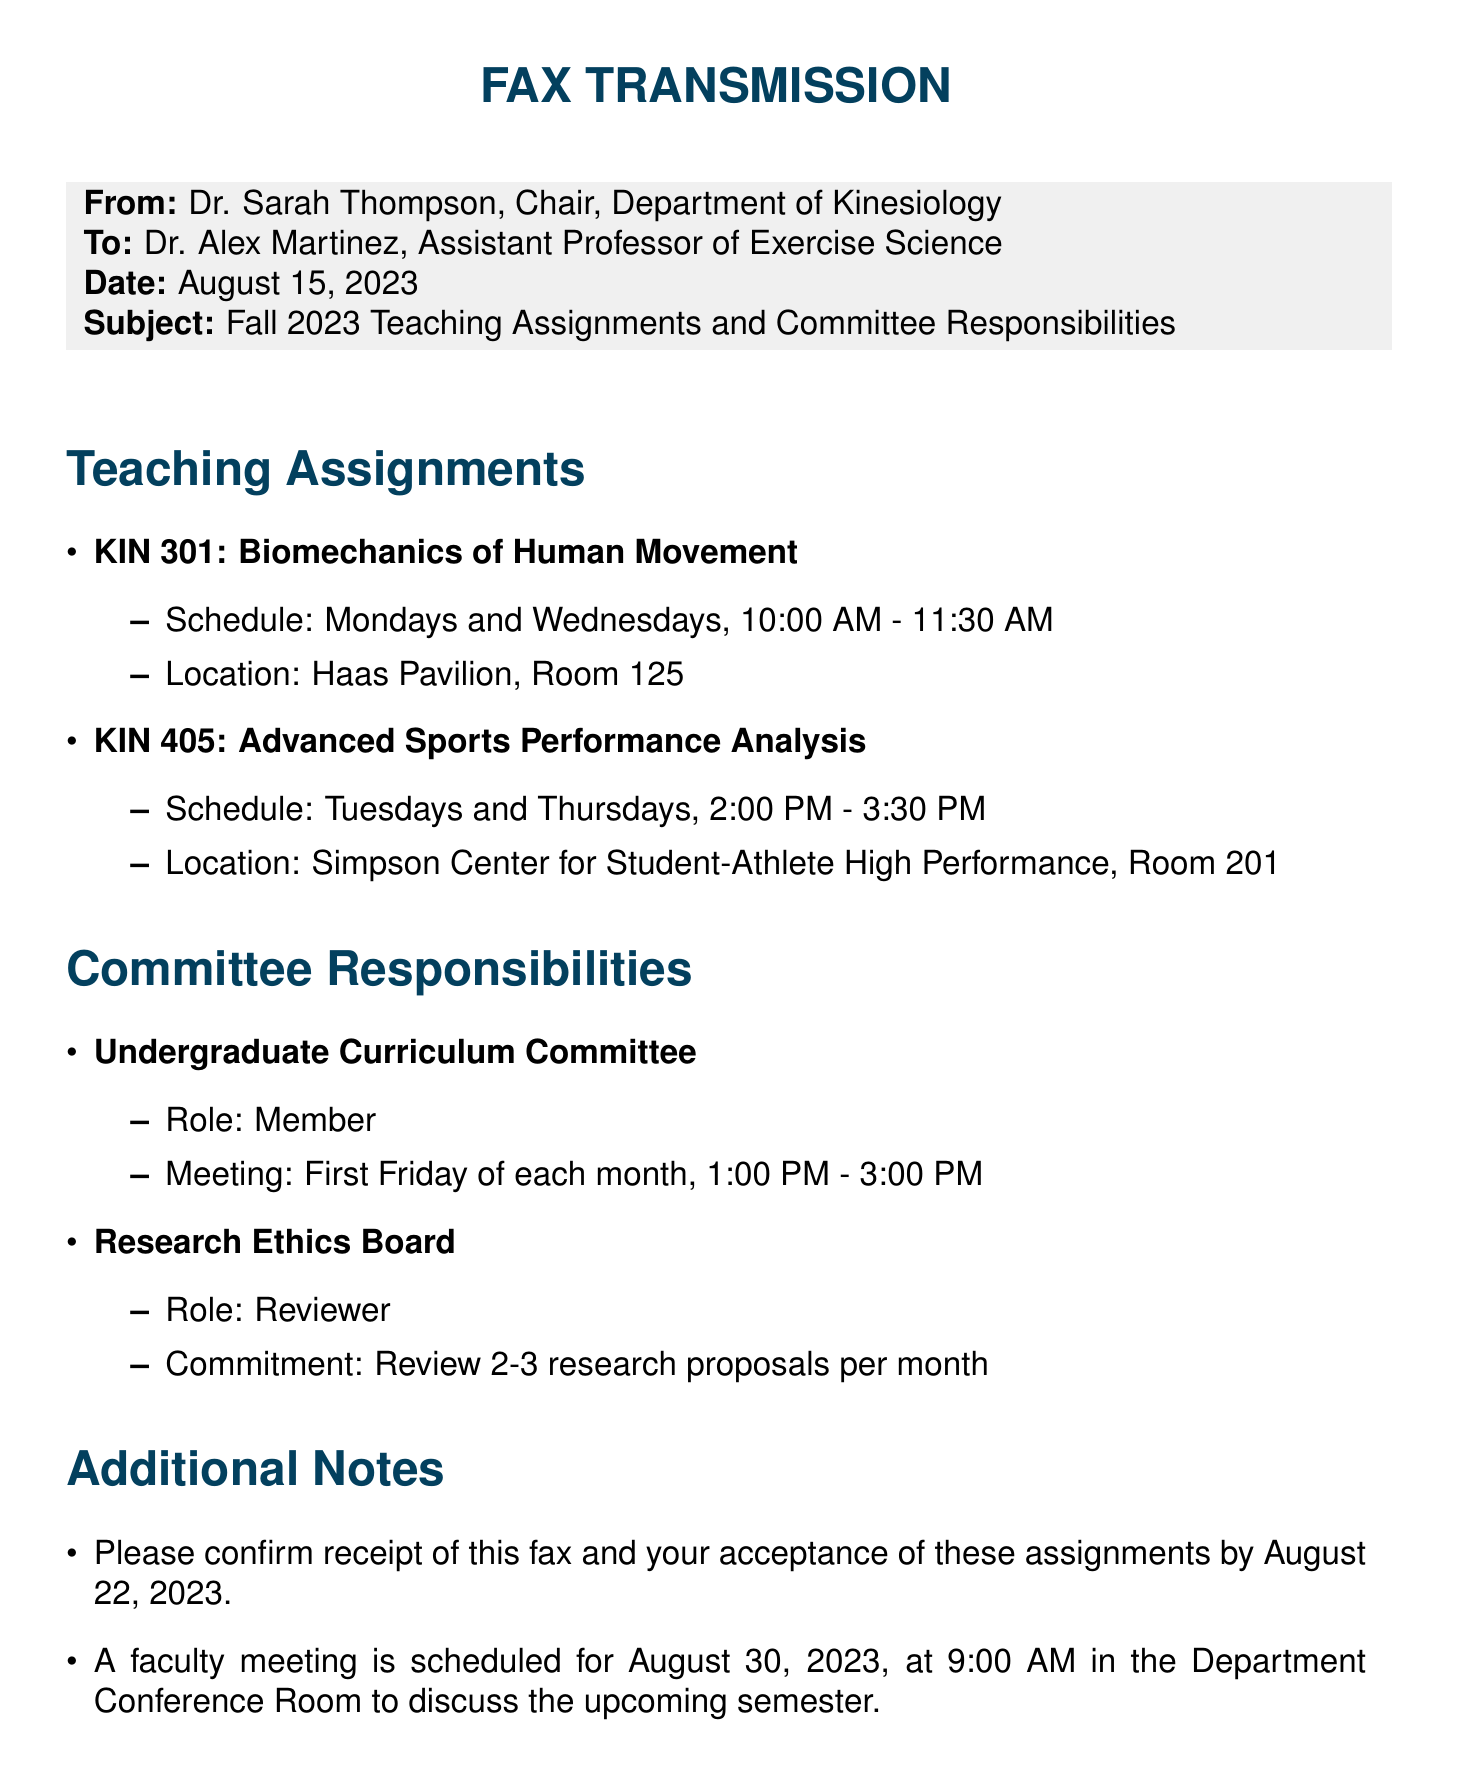what is the name of the sender? The sender is identified at the beginning of the fax as Dr. Sarah Thompson, Chair, Department of Kinesiology.
Answer: Dr. Sarah Thompson what is the date of the fax? The date of the fax is specified in the header section as August 15, 2023.
Answer: August 15, 2023 what is the first course listed in the teaching assignments? The first course listed is mentioned under teaching assignments as KIN 301: Biomechanics of Human Movement.
Answer: KIN 301: Biomechanics of Human Movement when is the faculty meeting scheduled? The faculty meeting date is mentioned under additional notes as August 30, 2023, at 9:00 AM.
Answer: August 30, 2023, at 9:00 AM what is Dr. Alex Martinez's role in the Undergraduate Curriculum Committee? The fax states that Dr. Alex Martinez's role in the Undergraduate Curriculum Committee is as a member.
Answer: Member how many research proposals does the Reviewer need to review per month? It is indicated that the commitment is to review 2-3 research proposals per month.
Answer: 2-3 research proposals where is the KIN 405 class held? The location for KIN 405: Advanced Sports Performance Analysis is mentioned as Simpson Center for Student-Athlete High Performance, Room 201.
Answer: Simpson Center for Student-Athlete High Performance, Room 201 what is the commitment required for the Research Ethics Board? The commitment required for the Research Ethics Board is to review 2-3 research proposals per month, as stated in the document.
Answer: Review 2-3 research proposals per month what color is used for the section titles? The color used for the section titles is specified as ucberkeley in the document.
Answer: ucberkeley 